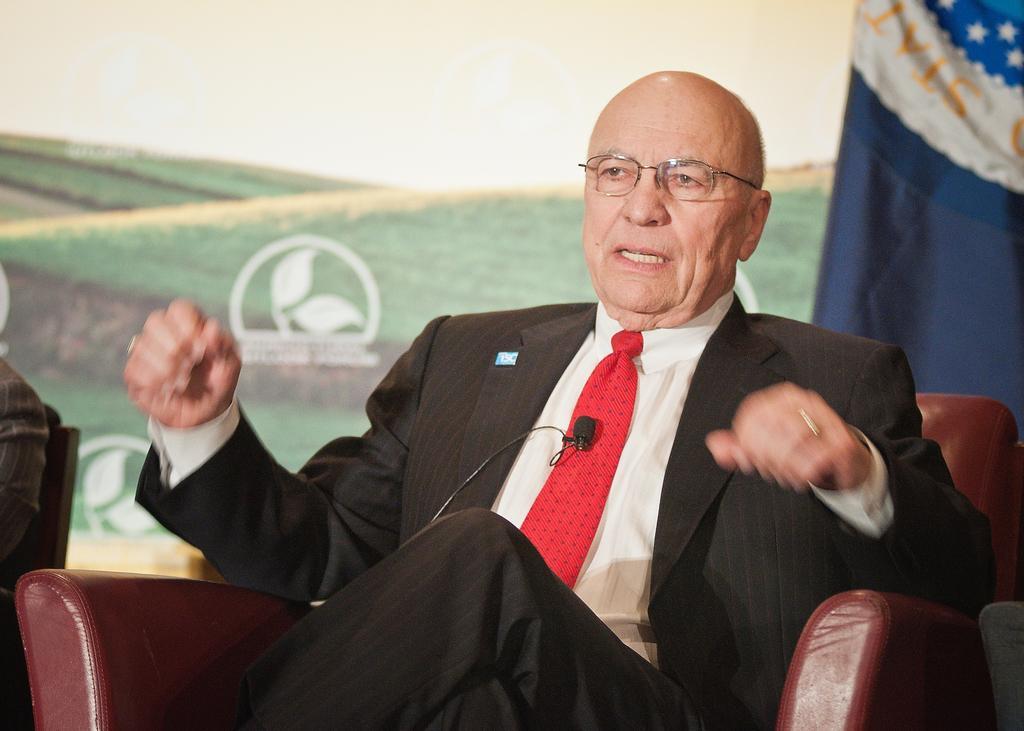How would you summarize this image in a sentence or two? In this picture there is a man sitting on the chair. There is also another person sitting on the chair. There is a blue cloth to the left and a poster in the background. 